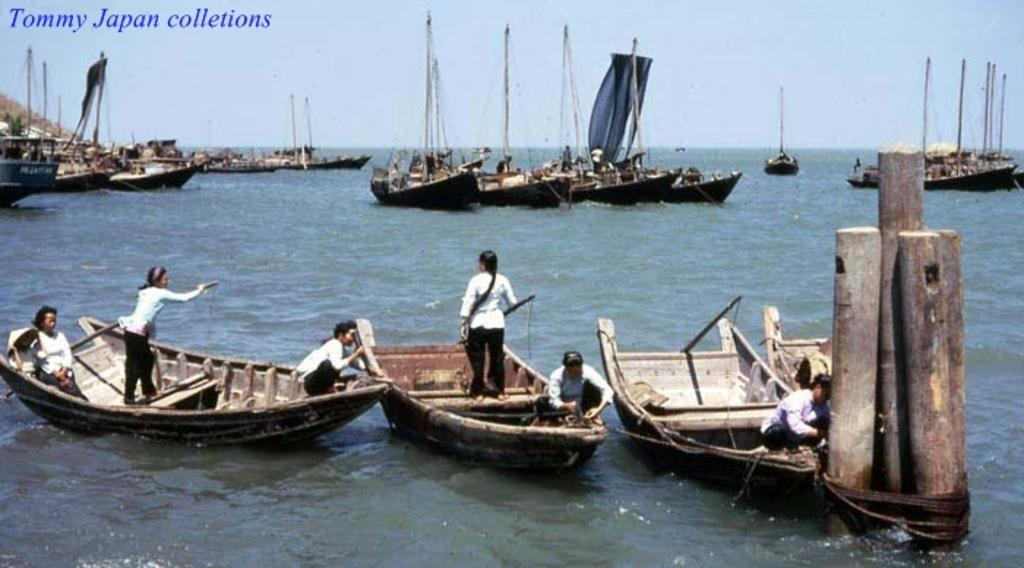What type of vehicles are in the image? There are boats and ships in the image. Where are the boats and ships located? The boats and ships are on the water. Can you describe the people in the image? People are present in the image. What is visible at the top of the image? There is sky visible at the top of the image. What type of natural feature is on the left side of the image? There are mountains on the left side of the image. Where is the crate located in the image? There is no crate present in the image. How many kittens are playing with the horses in the image? There are no kittens or horses present in the image. 